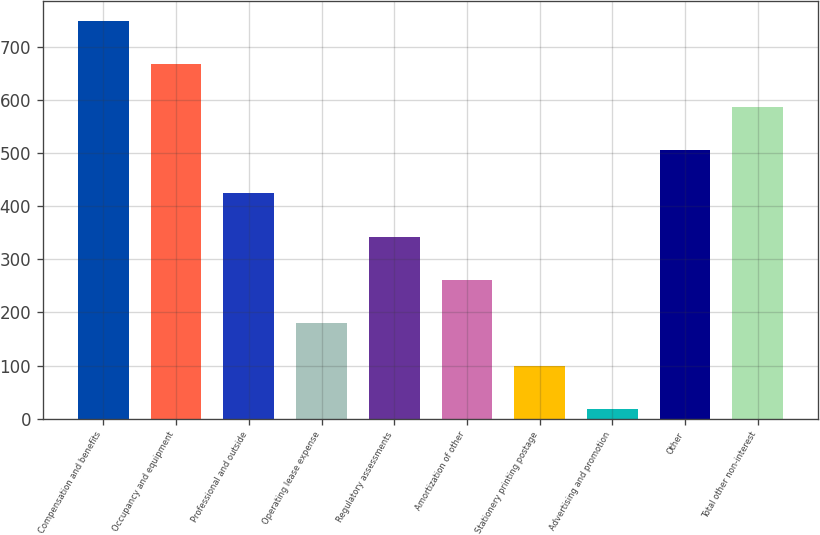<chart> <loc_0><loc_0><loc_500><loc_500><bar_chart><fcel>Compensation and benefits<fcel>Occupancy and equipment<fcel>Professional and outside<fcel>Operating lease expense<fcel>Regulatory assessments<fcel>Amortization of other<fcel>Stationery printing postage<fcel>Advertising and promotion<fcel>Other<fcel>Total other non-interest<nl><fcel>749.31<fcel>668.02<fcel>424.15<fcel>180.28<fcel>342.86<fcel>261.57<fcel>98.99<fcel>17.7<fcel>505.44<fcel>586.73<nl></chart> 